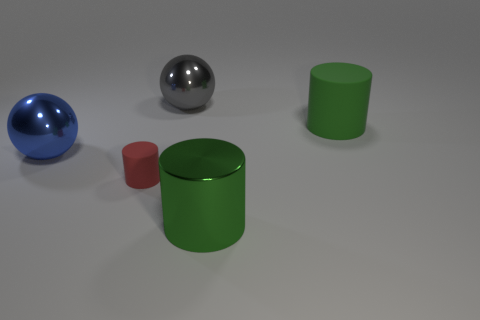Is there any other thing that has the same size as the red thing?
Ensure brevity in your answer.  No. Is the number of large metallic things that are behind the gray metallic ball less than the number of green objects that are behind the small red cylinder?
Your answer should be compact. Yes. There is a ball behind the big green cylinder that is behind the metal ball in front of the big gray object; what size is it?
Keep it short and to the point. Large. There is a green object that is in front of the red rubber cylinder; is its size the same as the large blue ball?
Your response must be concise. Yes. How many other objects are there of the same material as the small red cylinder?
Your answer should be compact. 1. Are there more gray balls than large green cubes?
Give a very brief answer. Yes. What material is the big green cylinder that is behind the big metallic object on the left side of the metal ball behind the blue object made of?
Your response must be concise. Rubber. Do the big rubber cylinder and the shiny cylinder have the same color?
Offer a very short reply. Yes. Are there any large matte objects that have the same color as the metallic cylinder?
Provide a short and direct response. Yes. What shape is the other green thing that is the same size as the green metallic object?
Your answer should be compact. Cylinder. 